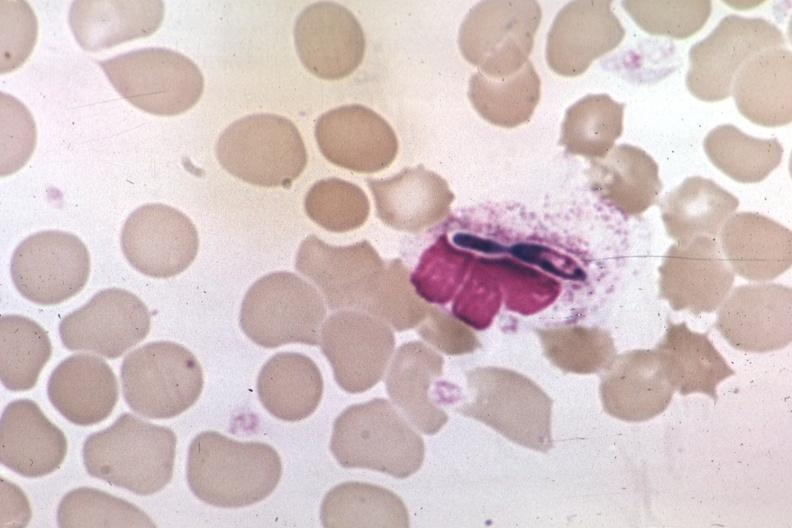s candida in peripheral blood present?
Answer the question using a single word or phrase. Yes 